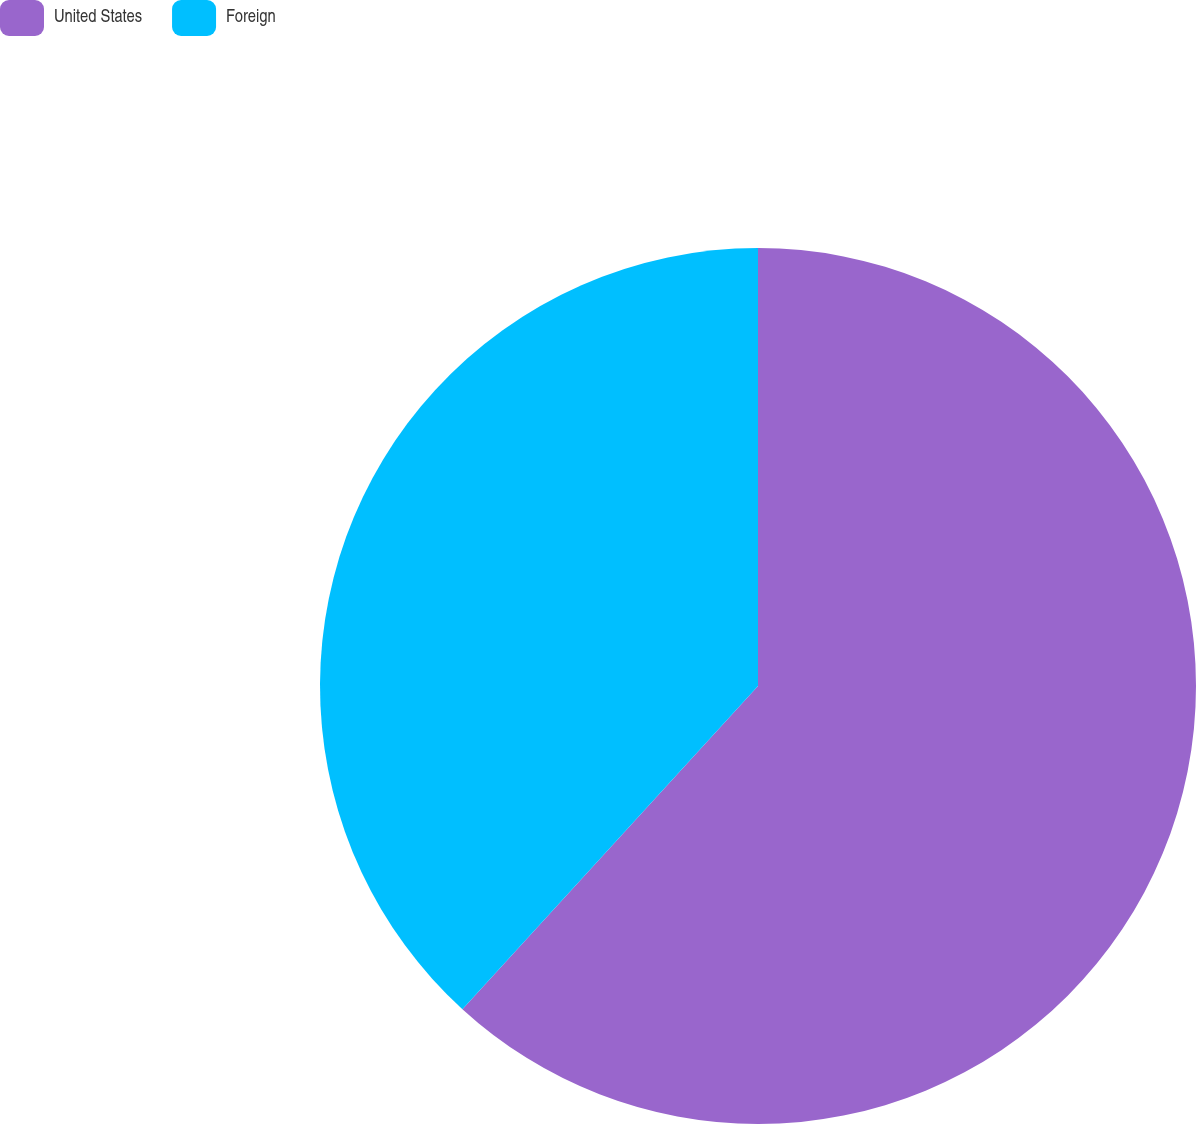Convert chart to OTSL. <chart><loc_0><loc_0><loc_500><loc_500><pie_chart><fcel>United States<fcel>Foreign<nl><fcel>61.79%<fcel>38.21%<nl></chart> 